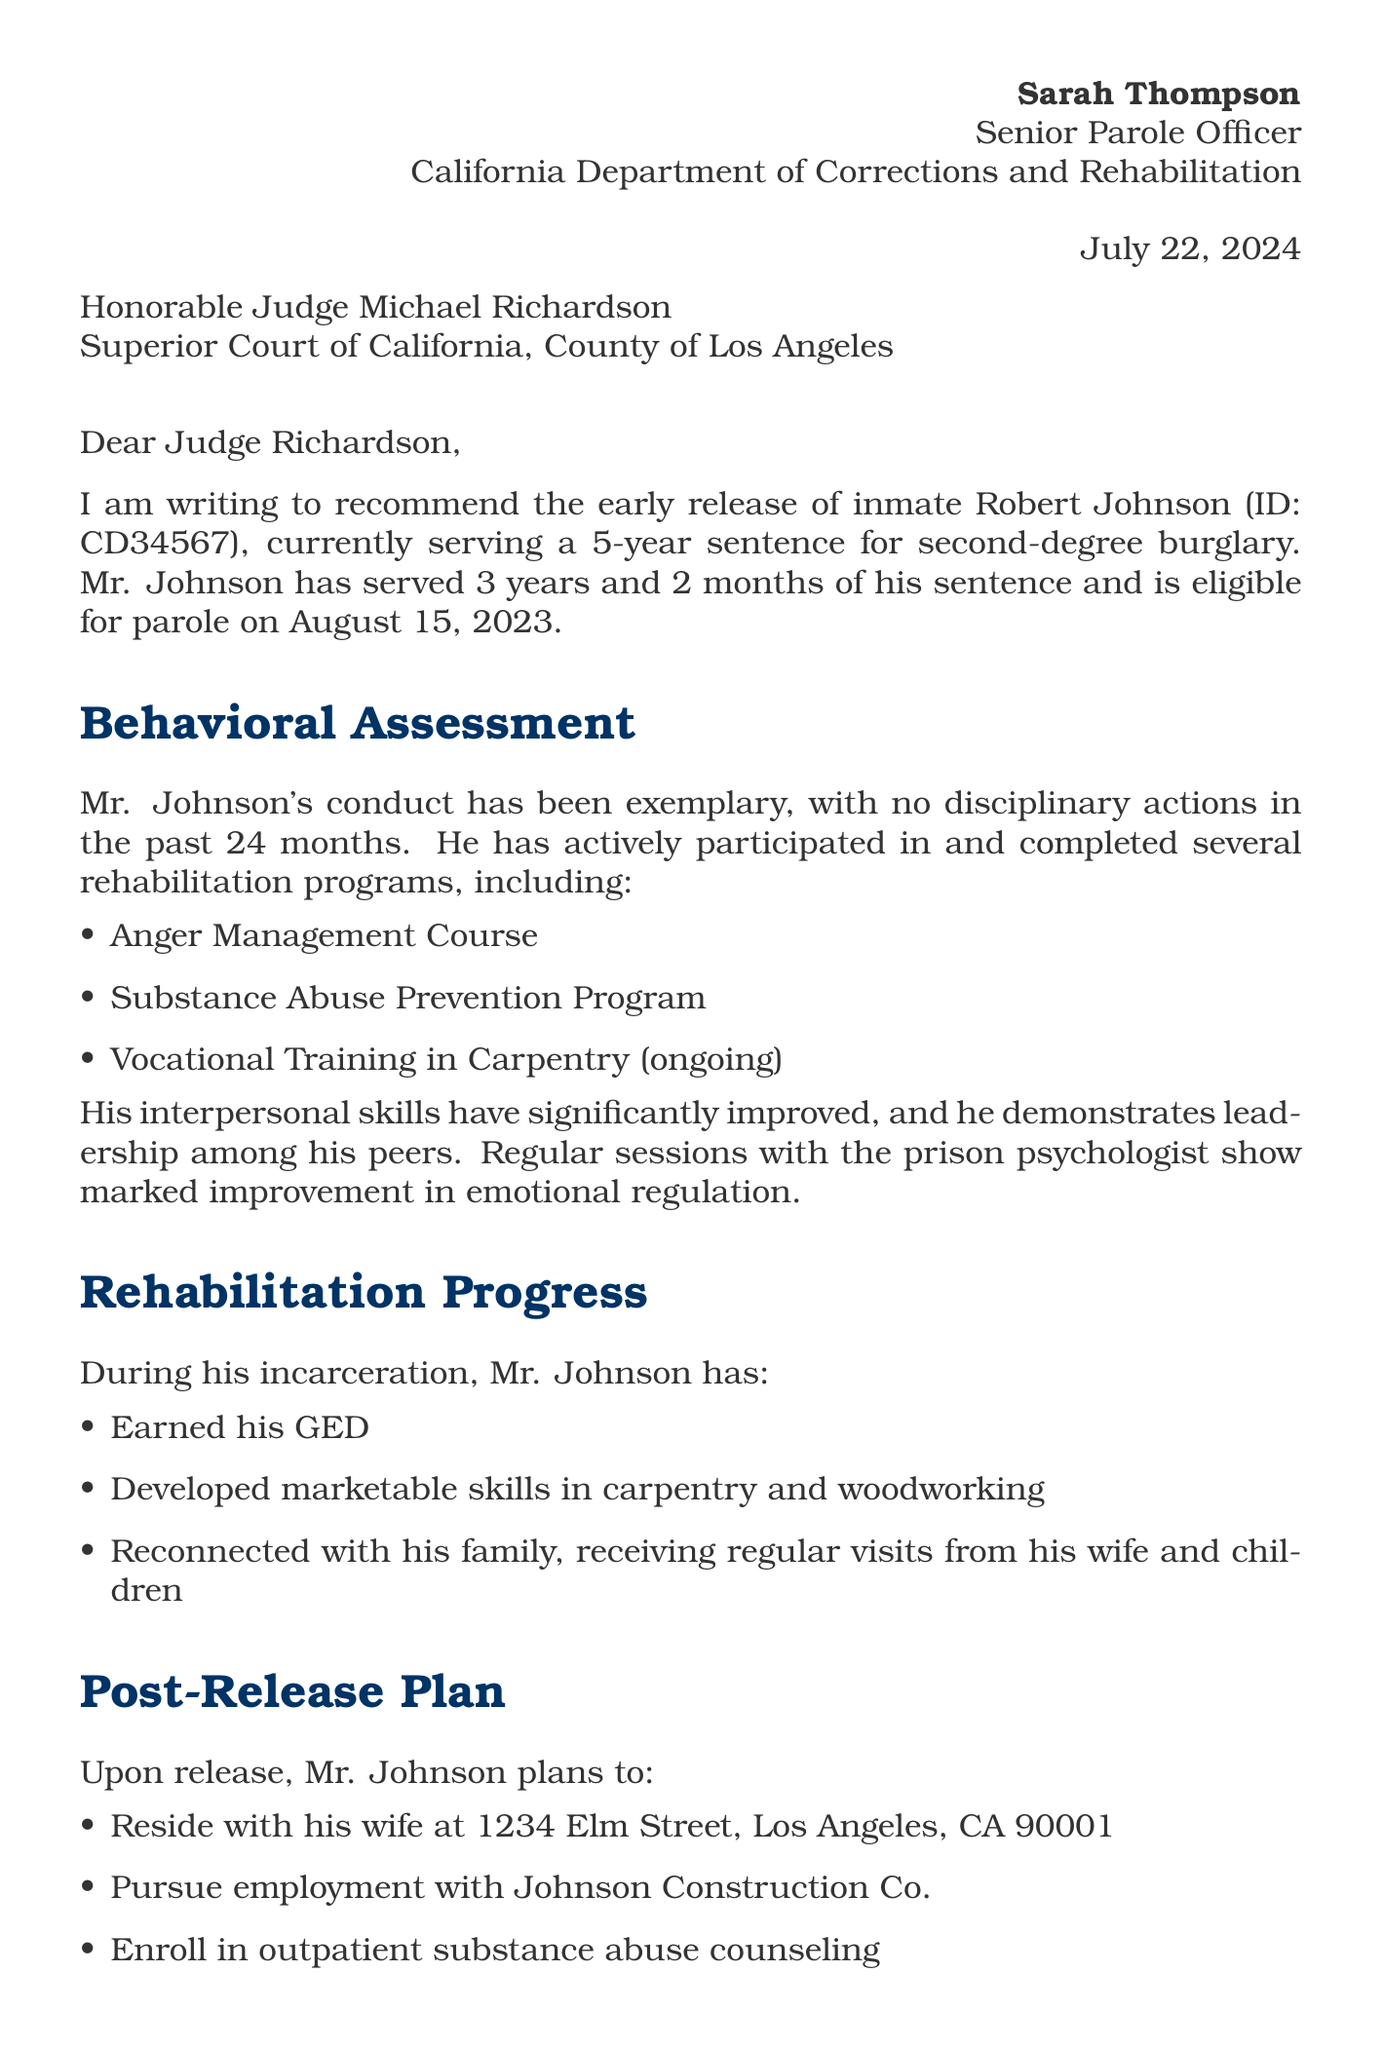What is the name of the parole officer? The name of the parole officer is stated in the letter header.
Answer: Sarah Thompson What is the conviction of the parolee? The conviction is mentioned in the parolee information section of the letter.
Answer: Second-degree burglary How long is Robert Johnson's sentence? The sentence duration is specified in the parolee information section.
Answer: 5 years When is Robert Johnson eligible for parole? The parole eligibility date is provided in the parolee information section.
Answer: August 15, 2023 How many hours of community service has Robert Johnson completed? The completed hours of community service are listed in the additional considerations section.
Answer: 300 hours What is the risk assessment of recidivism risk for Robert Johnson? The recidivism risk is included in the risk assessment section of the letter.
Answer: Low What programs has Robert Johnson completed? The programs completed are detailed in the behavioral assessment section.
Answer: Anger Management Course, Substance Abuse Prevention Program What is the post-release employment plan for Robert Johnson? The post-release employment plan is described in the post-release plan section.
Answer: Potential job offer from Johnson Construction Co What is the parole officer's recommendation regarding early release? The recommendation is summarized in the recommendation section of the letter.
Answer: Strong recommendation for early release What type of course is Robert Johnson currently participating in? The type of program he is currently involved in is noted in the behavioral assessment section.
Answer: Vocational Training in Carpentry (ongoing) 